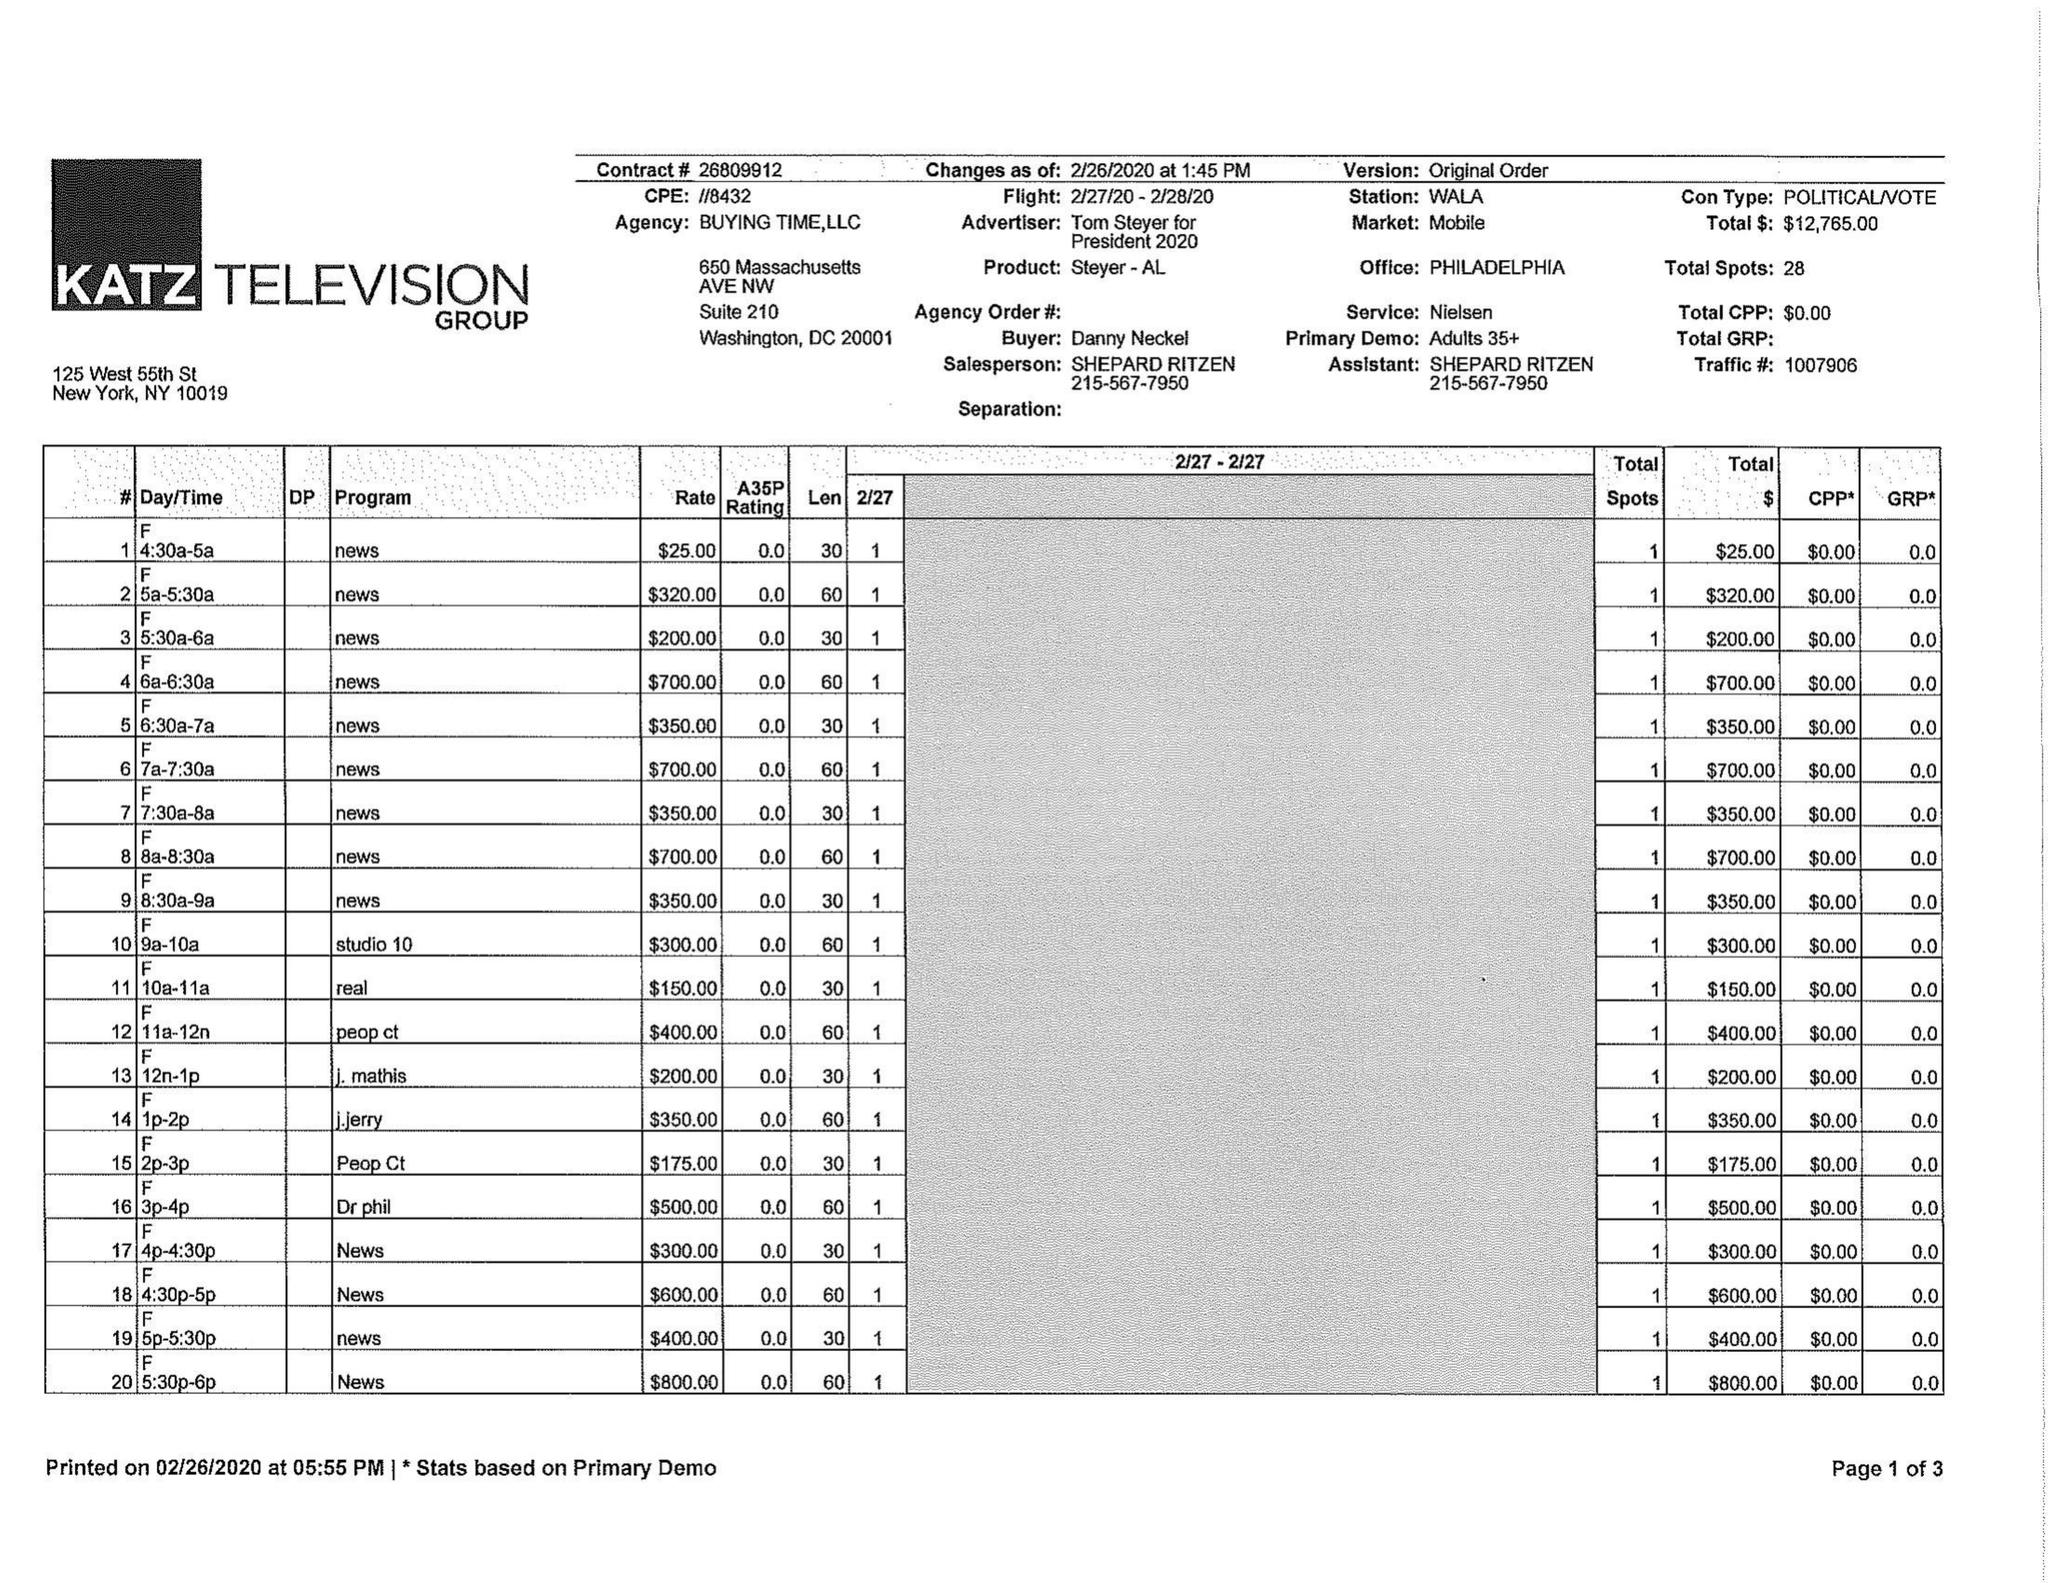What is the value for the gross_amount?
Answer the question using a single word or phrase. 12765.00 